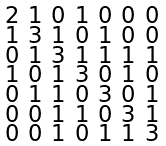Convert formula to latex. <formula><loc_0><loc_0><loc_500><loc_500>\begin{smallmatrix} 2 & 1 & 0 & 1 & 0 & 0 & 0 \\ 1 & 3 & 1 & 0 & 1 & 0 & 0 \\ 0 & 1 & 3 & 1 & 1 & 1 & 1 \\ 1 & 0 & 1 & 3 & 0 & 1 & 0 \\ 0 & 1 & 1 & 0 & 3 & 0 & 1 \\ 0 & 0 & 1 & 1 & 0 & 3 & 1 \\ 0 & 0 & 1 & 0 & 1 & 1 & 3 \end{smallmatrix}</formula> 